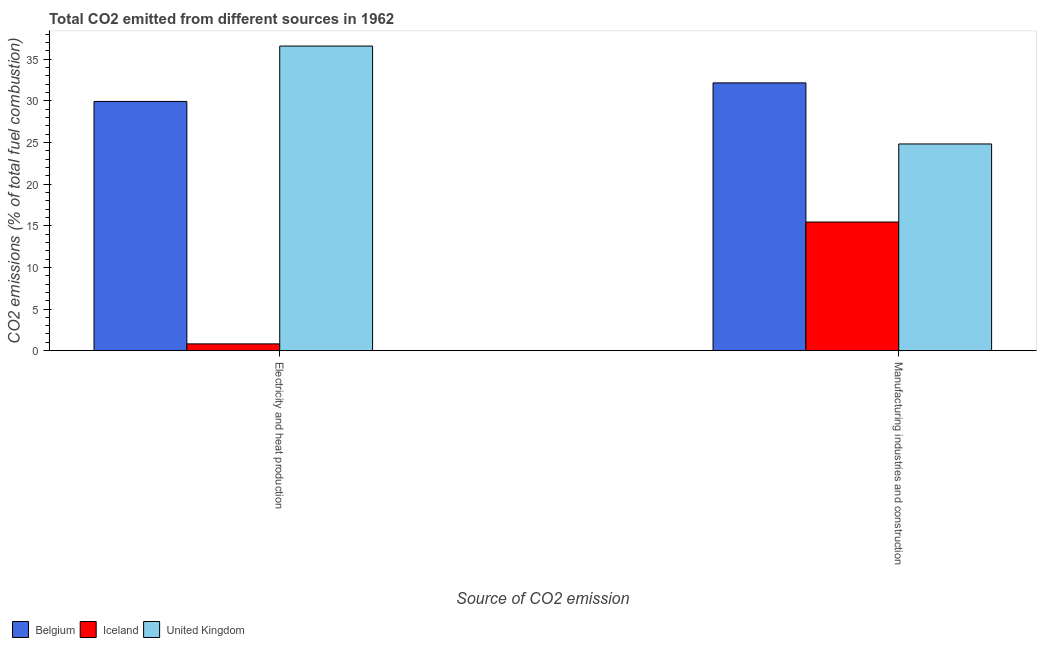Are the number of bars per tick equal to the number of legend labels?
Give a very brief answer. Yes. What is the label of the 1st group of bars from the left?
Your response must be concise. Electricity and heat production. What is the co2 emissions due to manufacturing industries in Iceland?
Give a very brief answer. 15.45. Across all countries, what is the maximum co2 emissions due to manufacturing industries?
Offer a terse response. 32.16. Across all countries, what is the minimum co2 emissions due to electricity and heat production?
Provide a short and direct response. 0.81. What is the total co2 emissions due to manufacturing industries in the graph?
Offer a terse response. 72.42. What is the difference between the co2 emissions due to electricity and heat production in United Kingdom and that in Belgium?
Offer a very short reply. 6.65. What is the difference between the co2 emissions due to manufacturing industries in United Kingdom and the co2 emissions due to electricity and heat production in Iceland?
Your response must be concise. 24.01. What is the average co2 emissions due to manufacturing industries per country?
Keep it short and to the point. 24.14. What is the difference between the co2 emissions due to manufacturing industries and co2 emissions due to electricity and heat production in Iceland?
Provide a succinct answer. 14.63. What is the ratio of the co2 emissions due to electricity and heat production in United Kingdom to that in Iceland?
Give a very brief answer. 44.99. How many bars are there?
Make the answer very short. 6. How many countries are there in the graph?
Your answer should be compact. 3. What is the difference between two consecutive major ticks on the Y-axis?
Your response must be concise. 5. Does the graph contain any zero values?
Give a very brief answer. No. Where does the legend appear in the graph?
Keep it short and to the point. Bottom left. How many legend labels are there?
Make the answer very short. 3. How are the legend labels stacked?
Provide a succinct answer. Horizontal. What is the title of the graph?
Provide a succinct answer. Total CO2 emitted from different sources in 1962. Does "Kiribati" appear as one of the legend labels in the graph?
Offer a very short reply. No. What is the label or title of the X-axis?
Offer a terse response. Source of CO2 emission. What is the label or title of the Y-axis?
Your answer should be compact. CO2 emissions (% of total fuel combustion). What is the CO2 emissions (% of total fuel combustion) of Belgium in Electricity and heat production?
Provide a short and direct response. 29.93. What is the CO2 emissions (% of total fuel combustion) of Iceland in Electricity and heat production?
Provide a short and direct response. 0.81. What is the CO2 emissions (% of total fuel combustion) of United Kingdom in Electricity and heat production?
Provide a succinct answer. 36.58. What is the CO2 emissions (% of total fuel combustion) of Belgium in Manufacturing industries and construction?
Your answer should be compact. 32.16. What is the CO2 emissions (% of total fuel combustion) of Iceland in Manufacturing industries and construction?
Offer a very short reply. 15.45. What is the CO2 emissions (% of total fuel combustion) of United Kingdom in Manufacturing industries and construction?
Give a very brief answer. 24.82. Across all Source of CO2 emission, what is the maximum CO2 emissions (% of total fuel combustion) in Belgium?
Offer a very short reply. 32.16. Across all Source of CO2 emission, what is the maximum CO2 emissions (% of total fuel combustion) of Iceland?
Keep it short and to the point. 15.45. Across all Source of CO2 emission, what is the maximum CO2 emissions (% of total fuel combustion) of United Kingdom?
Ensure brevity in your answer.  36.58. Across all Source of CO2 emission, what is the minimum CO2 emissions (% of total fuel combustion) of Belgium?
Offer a very short reply. 29.93. Across all Source of CO2 emission, what is the minimum CO2 emissions (% of total fuel combustion) of Iceland?
Provide a succinct answer. 0.81. Across all Source of CO2 emission, what is the minimum CO2 emissions (% of total fuel combustion) in United Kingdom?
Offer a very short reply. 24.82. What is the total CO2 emissions (% of total fuel combustion) in Belgium in the graph?
Offer a very short reply. 62.08. What is the total CO2 emissions (% of total fuel combustion) of Iceland in the graph?
Keep it short and to the point. 16.26. What is the total CO2 emissions (% of total fuel combustion) in United Kingdom in the graph?
Keep it short and to the point. 61.4. What is the difference between the CO2 emissions (% of total fuel combustion) of Belgium in Electricity and heat production and that in Manufacturing industries and construction?
Your response must be concise. -2.23. What is the difference between the CO2 emissions (% of total fuel combustion) of Iceland in Electricity and heat production and that in Manufacturing industries and construction?
Keep it short and to the point. -14.63. What is the difference between the CO2 emissions (% of total fuel combustion) of United Kingdom in Electricity and heat production and that in Manufacturing industries and construction?
Offer a very short reply. 11.76. What is the difference between the CO2 emissions (% of total fuel combustion) in Belgium in Electricity and heat production and the CO2 emissions (% of total fuel combustion) in Iceland in Manufacturing industries and construction?
Provide a short and direct response. 14.48. What is the difference between the CO2 emissions (% of total fuel combustion) in Belgium in Electricity and heat production and the CO2 emissions (% of total fuel combustion) in United Kingdom in Manufacturing industries and construction?
Provide a succinct answer. 5.11. What is the difference between the CO2 emissions (% of total fuel combustion) of Iceland in Electricity and heat production and the CO2 emissions (% of total fuel combustion) of United Kingdom in Manufacturing industries and construction?
Offer a terse response. -24.01. What is the average CO2 emissions (% of total fuel combustion) of Belgium per Source of CO2 emission?
Provide a short and direct response. 31.04. What is the average CO2 emissions (% of total fuel combustion) of Iceland per Source of CO2 emission?
Make the answer very short. 8.13. What is the average CO2 emissions (% of total fuel combustion) in United Kingdom per Source of CO2 emission?
Give a very brief answer. 30.7. What is the difference between the CO2 emissions (% of total fuel combustion) in Belgium and CO2 emissions (% of total fuel combustion) in Iceland in Electricity and heat production?
Make the answer very short. 29.11. What is the difference between the CO2 emissions (% of total fuel combustion) of Belgium and CO2 emissions (% of total fuel combustion) of United Kingdom in Electricity and heat production?
Give a very brief answer. -6.65. What is the difference between the CO2 emissions (% of total fuel combustion) in Iceland and CO2 emissions (% of total fuel combustion) in United Kingdom in Electricity and heat production?
Give a very brief answer. -35.77. What is the difference between the CO2 emissions (% of total fuel combustion) of Belgium and CO2 emissions (% of total fuel combustion) of Iceland in Manufacturing industries and construction?
Ensure brevity in your answer.  16.71. What is the difference between the CO2 emissions (% of total fuel combustion) of Belgium and CO2 emissions (% of total fuel combustion) of United Kingdom in Manufacturing industries and construction?
Your response must be concise. 7.33. What is the difference between the CO2 emissions (% of total fuel combustion) of Iceland and CO2 emissions (% of total fuel combustion) of United Kingdom in Manufacturing industries and construction?
Keep it short and to the point. -9.37. What is the ratio of the CO2 emissions (% of total fuel combustion) of Belgium in Electricity and heat production to that in Manufacturing industries and construction?
Make the answer very short. 0.93. What is the ratio of the CO2 emissions (% of total fuel combustion) in Iceland in Electricity and heat production to that in Manufacturing industries and construction?
Offer a terse response. 0.05. What is the ratio of the CO2 emissions (% of total fuel combustion) of United Kingdom in Electricity and heat production to that in Manufacturing industries and construction?
Provide a succinct answer. 1.47. What is the difference between the highest and the second highest CO2 emissions (% of total fuel combustion) in Belgium?
Your answer should be compact. 2.23. What is the difference between the highest and the second highest CO2 emissions (% of total fuel combustion) of Iceland?
Keep it short and to the point. 14.63. What is the difference between the highest and the second highest CO2 emissions (% of total fuel combustion) in United Kingdom?
Provide a short and direct response. 11.76. What is the difference between the highest and the lowest CO2 emissions (% of total fuel combustion) of Belgium?
Provide a short and direct response. 2.23. What is the difference between the highest and the lowest CO2 emissions (% of total fuel combustion) of Iceland?
Offer a terse response. 14.63. What is the difference between the highest and the lowest CO2 emissions (% of total fuel combustion) of United Kingdom?
Ensure brevity in your answer.  11.76. 